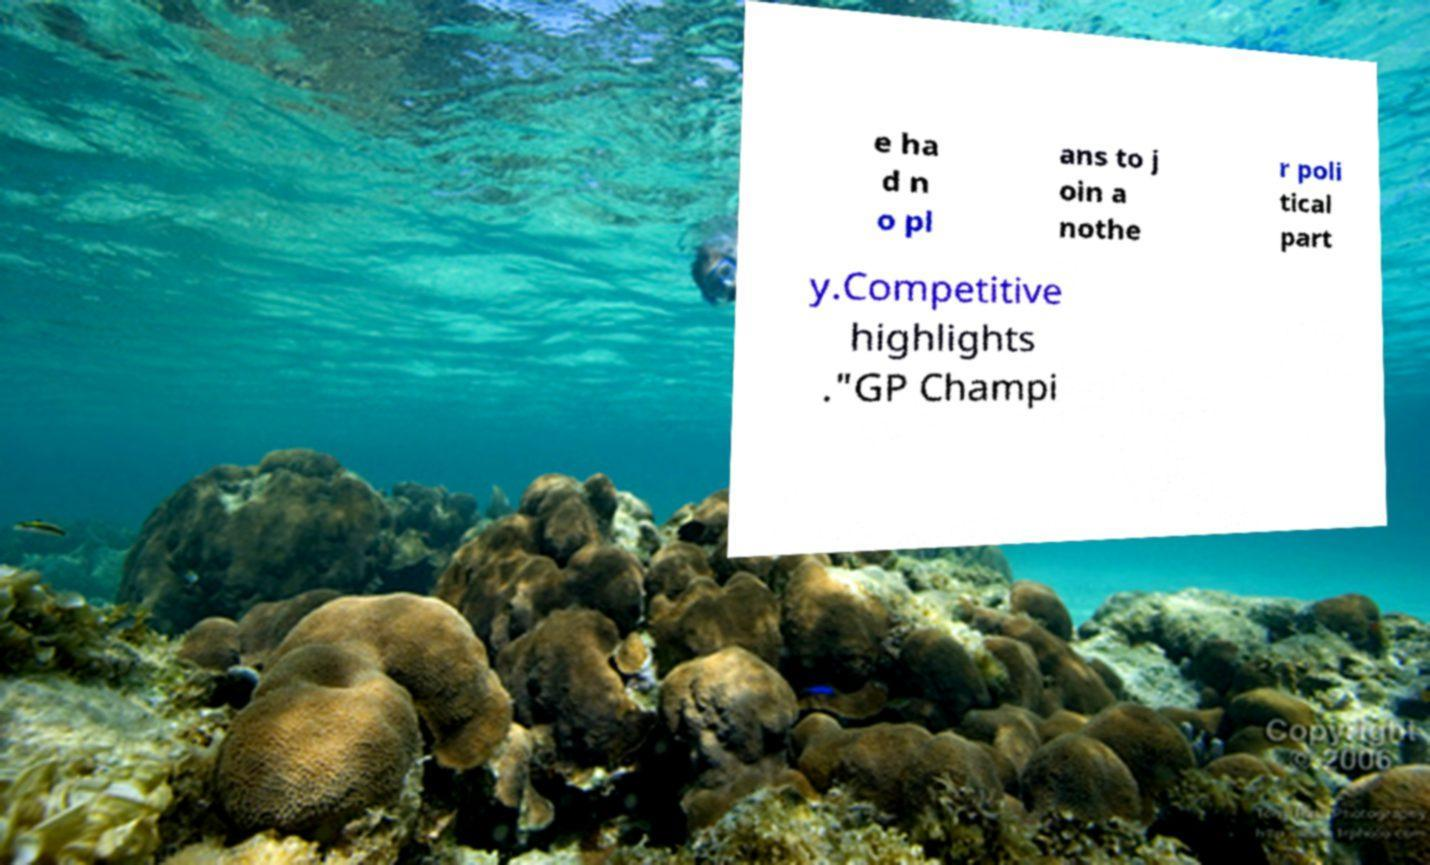What messages or text are displayed in this image? I need them in a readable, typed format. e ha d n o pl ans to j oin a nothe r poli tical part y.Competitive highlights ."GP Champi 